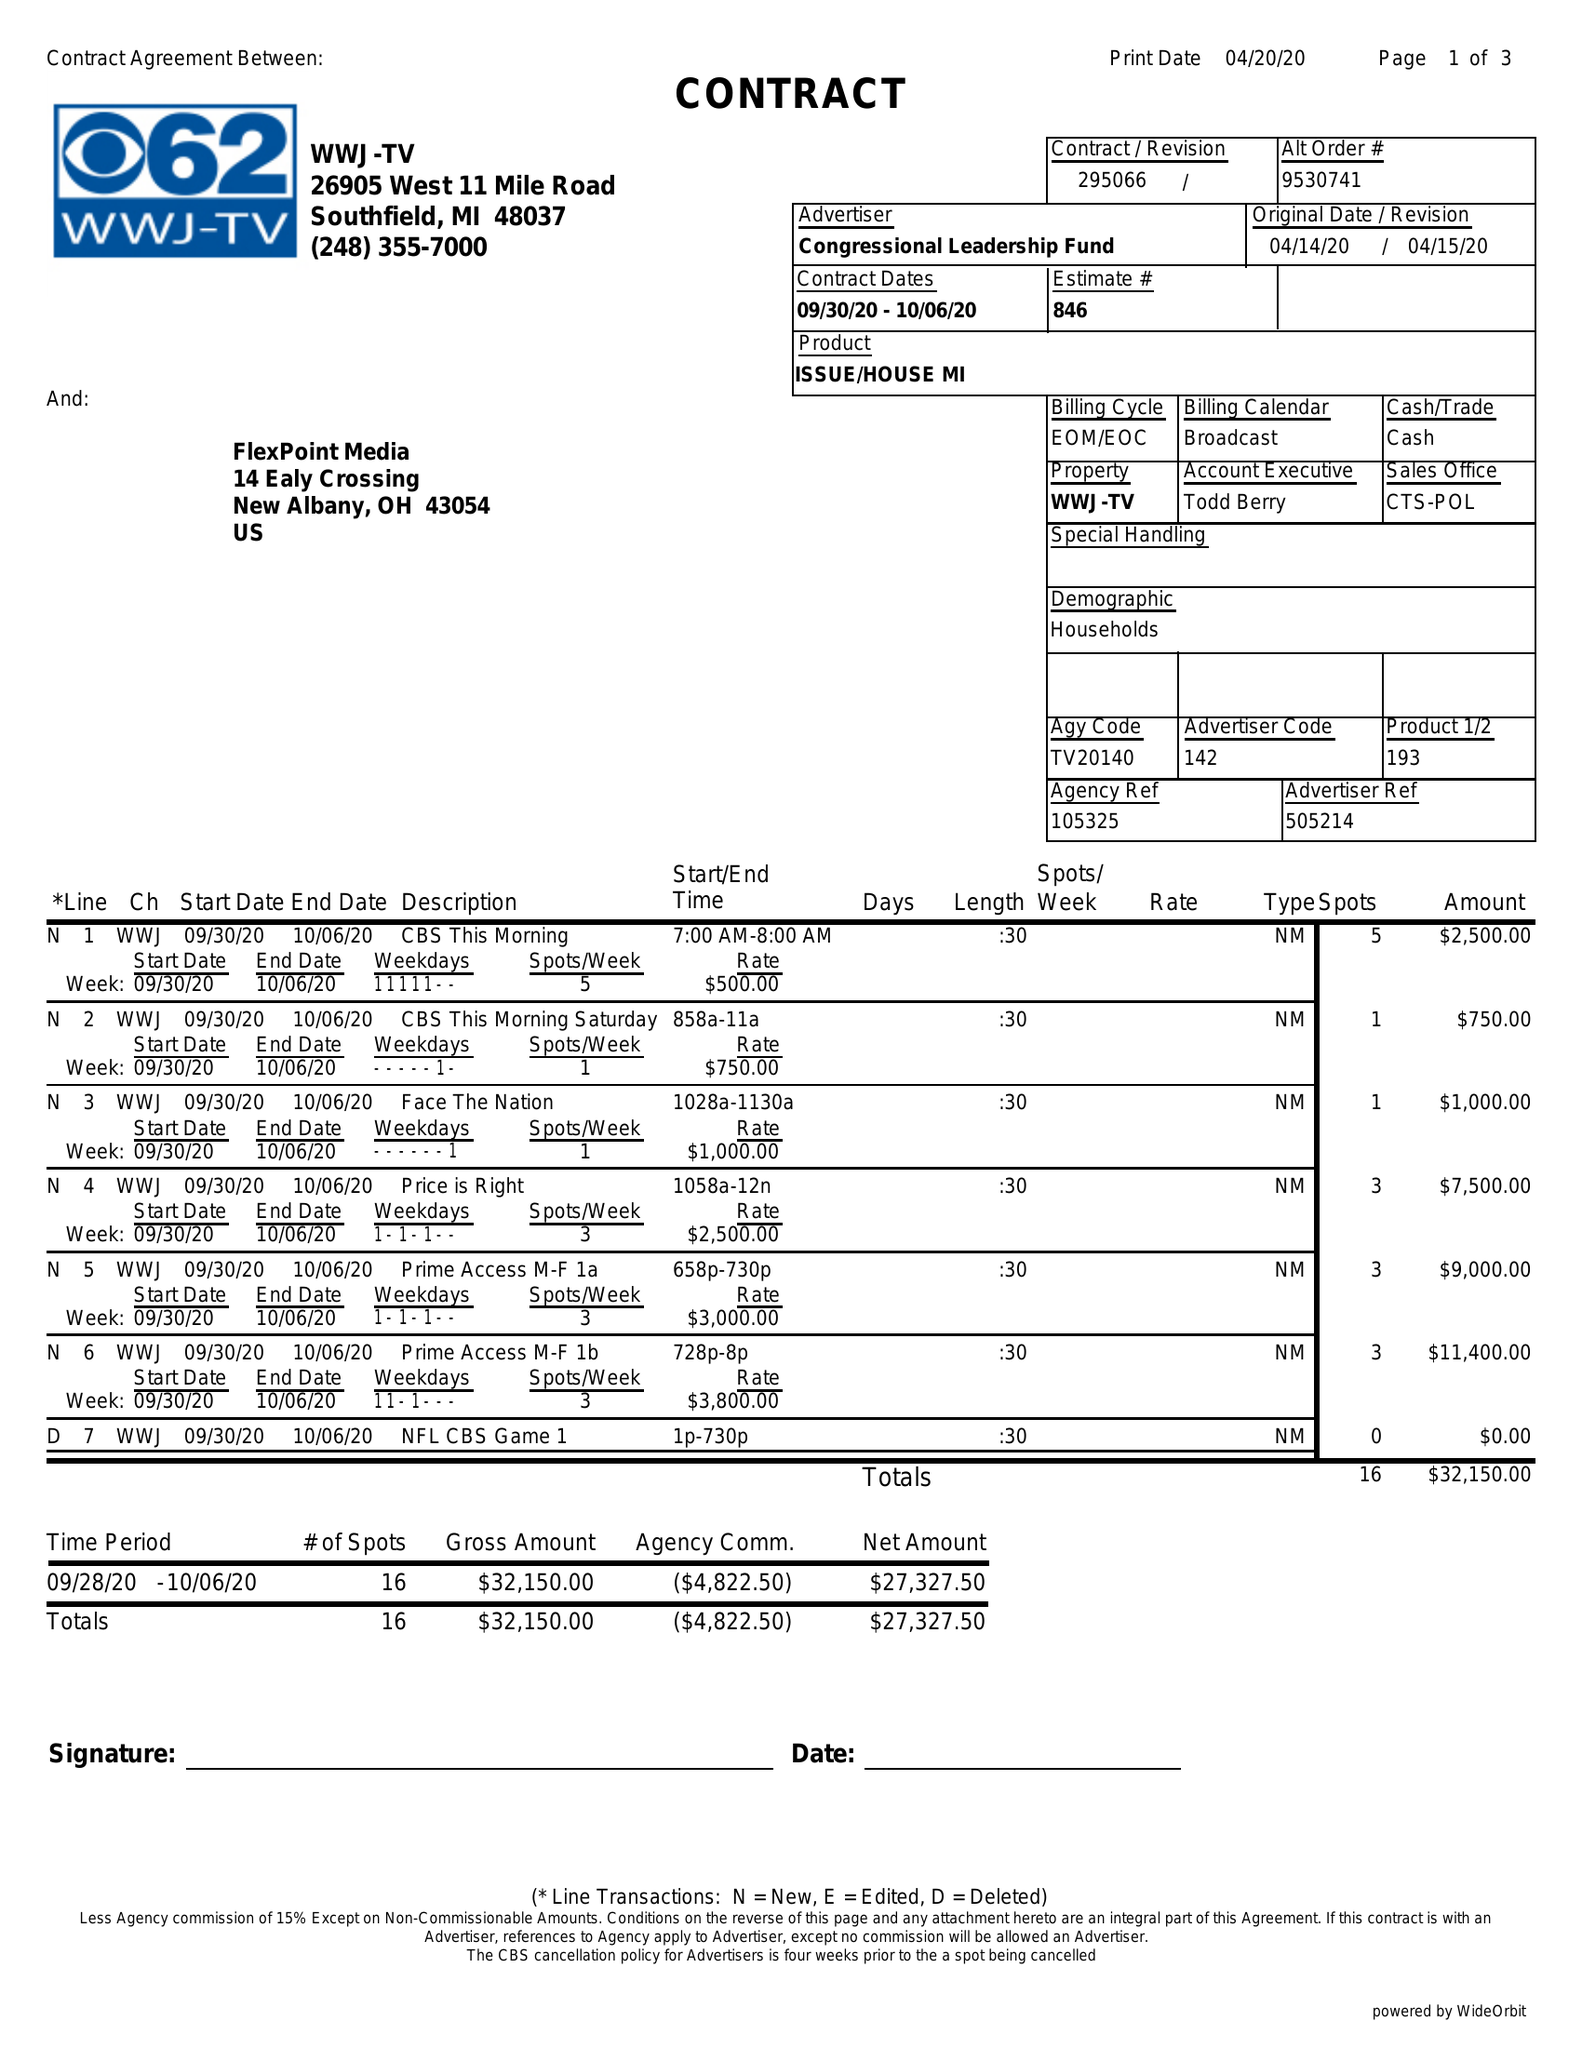What is the value for the advertiser?
Answer the question using a single word or phrase. CONGRESSIONAL LEADERSHIP FUND 